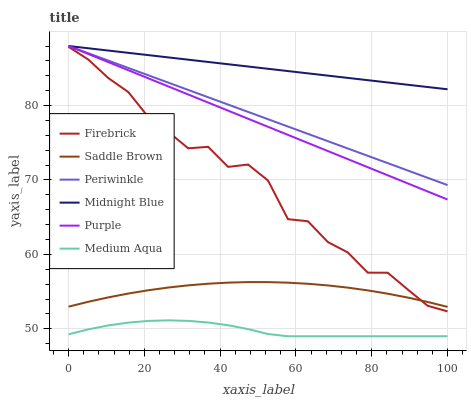Does Medium Aqua have the minimum area under the curve?
Answer yes or no. Yes. Does Midnight Blue have the maximum area under the curve?
Answer yes or no. Yes. Does Purple have the minimum area under the curve?
Answer yes or no. No. Does Purple have the maximum area under the curve?
Answer yes or no. No. Is Purple the smoothest?
Answer yes or no. Yes. Is Firebrick the roughest?
Answer yes or no. Yes. Is Firebrick the smoothest?
Answer yes or no. No. Is Purple the roughest?
Answer yes or no. No. Does Purple have the lowest value?
Answer yes or no. No. Does Firebrick have the highest value?
Answer yes or no. No. Is Saddle Brown less than Purple?
Answer yes or no. Yes. Is Periwinkle greater than Saddle Brown?
Answer yes or no. Yes. Does Saddle Brown intersect Purple?
Answer yes or no. No. 